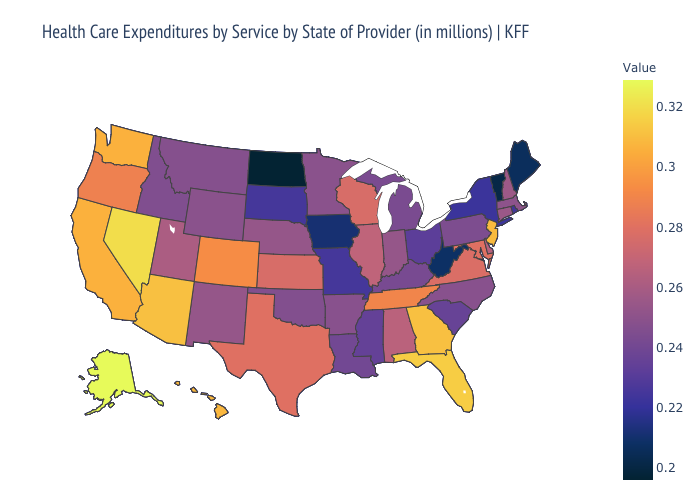Among the states that border North Dakota , does South Dakota have the lowest value?
Be succinct. Yes. Does Oklahoma have a lower value than Illinois?
Answer briefly. Yes. Among the states that border New York , which have the highest value?
Give a very brief answer. New Jersey. Among the states that border North Dakota , does Minnesota have the highest value?
Write a very short answer. Yes. 